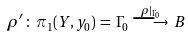Convert formula to latex. <formula><loc_0><loc_0><loc_500><loc_500>\rho ^ { \prime } \, \colon \, \pi _ { 1 } ( Y , y _ { 0 } ) \, = \, \Gamma _ { 0 } \, \stackrel { \rho | _ { \Gamma _ { 0 } } } { \longrightarrow } \, B</formula> 